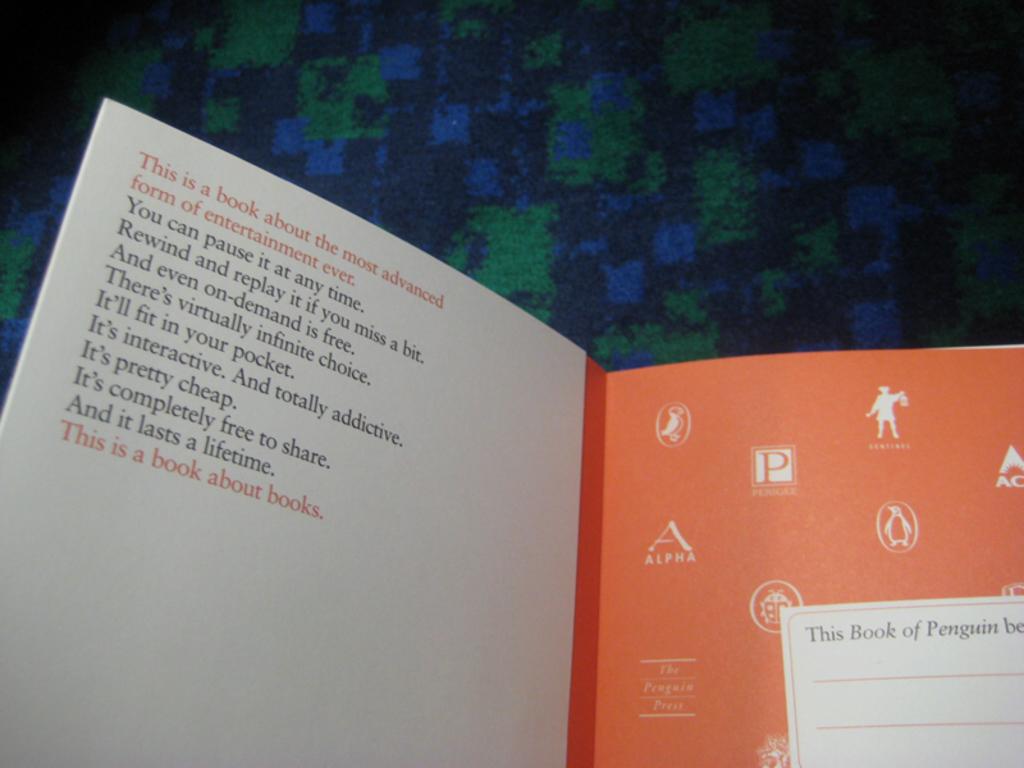What animal is mentioned on the right page?
Your answer should be compact. Penguin. 